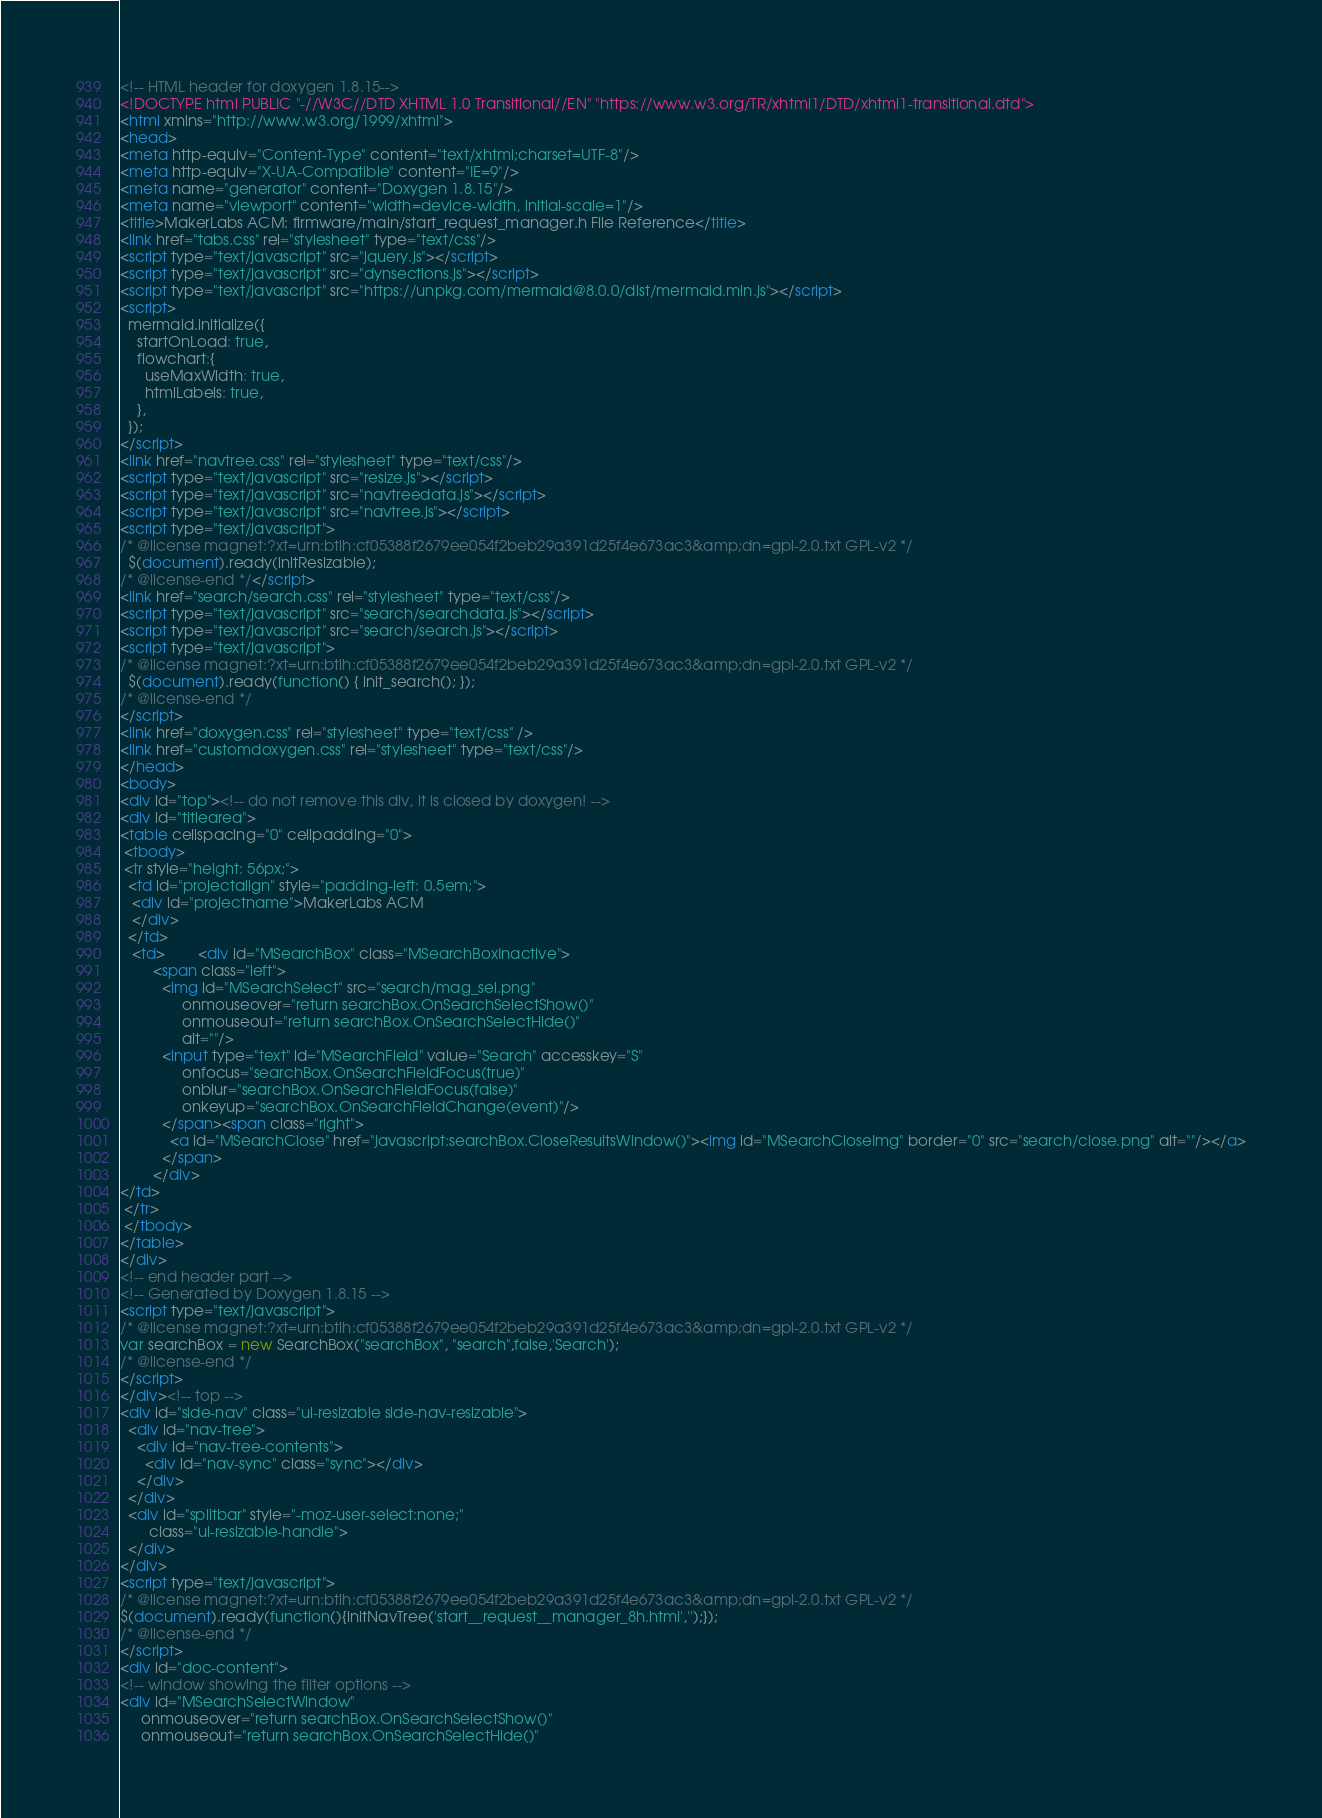<code> <loc_0><loc_0><loc_500><loc_500><_HTML_><!-- HTML header for doxygen 1.8.15-->
<!DOCTYPE html PUBLIC "-//W3C//DTD XHTML 1.0 Transitional//EN" "https://www.w3.org/TR/xhtml1/DTD/xhtml1-transitional.dtd">
<html xmlns="http://www.w3.org/1999/xhtml">
<head>
<meta http-equiv="Content-Type" content="text/xhtml;charset=UTF-8"/>
<meta http-equiv="X-UA-Compatible" content="IE=9"/>
<meta name="generator" content="Doxygen 1.8.15"/>
<meta name="viewport" content="width=device-width, initial-scale=1"/>
<title>MakerLabs ACM: firmware/main/start_request_manager.h File Reference</title>
<link href="tabs.css" rel="stylesheet" type="text/css"/>
<script type="text/javascript" src="jquery.js"></script>
<script type="text/javascript" src="dynsections.js"></script>
<script type="text/javascript" src="https://unpkg.com/mermaid@8.0.0/dist/mermaid.min.js"></script>
<script>
  mermaid.initialize({
    startOnLoad: true,
    flowchart:{
      useMaxWidth: true,
      htmlLabels: true,
    },
  });
</script>
<link href="navtree.css" rel="stylesheet" type="text/css"/>
<script type="text/javascript" src="resize.js"></script>
<script type="text/javascript" src="navtreedata.js"></script>
<script type="text/javascript" src="navtree.js"></script>
<script type="text/javascript">
/* @license magnet:?xt=urn:btih:cf05388f2679ee054f2beb29a391d25f4e673ac3&amp;dn=gpl-2.0.txt GPL-v2 */
  $(document).ready(initResizable);
/* @license-end */</script>
<link href="search/search.css" rel="stylesheet" type="text/css"/>
<script type="text/javascript" src="search/searchdata.js"></script>
<script type="text/javascript" src="search/search.js"></script>
<script type="text/javascript">
/* @license magnet:?xt=urn:btih:cf05388f2679ee054f2beb29a391d25f4e673ac3&amp;dn=gpl-2.0.txt GPL-v2 */
  $(document).ready(function() { init_search(); });
/* @license-end */
</script>
<link href="doxygen.css" rel="stylesheet" type="text/css" />
<link href="customdoxygen.css" rel="stylesheet" type="text/css"/>
</head>
<body>
<div id="top"><!-- do not remove this div, it is closed by doxygen! -->
<div id="titlearea">
<table cellspacing="0" cellpadding="0">
 <tbody>
 <tr style="height: 56px;">
  <td id="projectalign" style="padding-left: 0.5em;">
   <div id="projectname">MakerLabs ACM
   </div>
  </td>
   <td>        <div id="MSearchBox" class="MSearchBoxInactive">
        <span class="left">
          <img id="MSearchSelect" src="search/mag_sel.png"
               onmouseover="return searchBox.OnSearchSelectShow()"
               onmouseout="return searchBox.OnSearchSelectHide()"
               alt=""/>
          <input type="text" id="MSearchField" value="Search" accesskey="S"
               onfocus="searchBox.OnSearchFieldFocus(true)" 
               onblur="searchBox.OnSearchFieldFocus(false)" 
               onkeyup="searchBox.OnSearchFieldChange(event)"/>
          </span><span class="right">
            <a id="MSearchClose" href="javascript:searchBox.CloseResultsWindow()"><img id="MSearchCloseImg" border="0" src="search/close.png" alt=""/></a>
          </span>
        </div>
</td>
 </tr>
 </tbody>
</table>
</div>
<!-- end header part -->
<!-- Generated by Doxygen 1.8.15 -->
<script type="text/javascript">
/* @license magnet:?xt=urn:btih:cf05388f2679ee054f2beb29a391d25f4e673ac3&amp;dn=gpl-2.0.txt GPL-v2 */
var searchBox = new SearchBox("searchBox", "search",false,'Search');
/* @license-end */
</script>
</div><!-- top -->
<div id="side-nav" class="ui-resizable side-nav-resizable">
  <div id="nav-tree">
    <div id="nav-tree-contents">
      <div id="nav-sync" class="sync"></div>
    </div>
  </div>
  <div id="splitbar" style="-moz-user-select:none;" 
       class="ui-resizable-handle">
  </div>
</div>
<script type="text/javascript">
/* @license magnet:?xt=urn:btih:cf05388f2679ee054f2beb29a391d25f4e673ac3&amp;dn=gpl-2.0.txt GPL-v2 */
$(document).ready(function(){initNavTree('start__request__manager_8h.html','');});
/* @license-end */
</script>
<div id="doc-content">
<!-- window showing the filter options -->
<div id="MSearchSelectWindow"
     onmouseover="return searchBox.OnSearchSelectShow()"
     onmouseout="return searchBox.OnSearchSelectHide()"</code> 